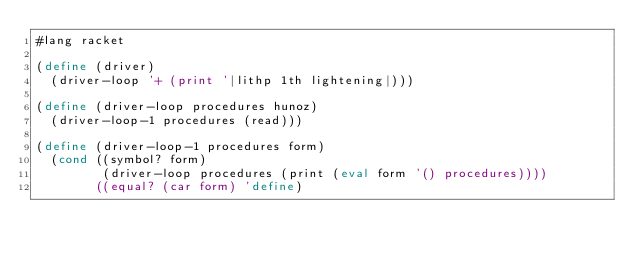Convert code to text. <code><loc_0><loc_0><loc_500><loc_500><_Scheme_>#lang racket

(define (driver)
  (driver-loop '+ (print '|lithp 1th lightening|)))

(define (driver-loop procedures hunoz)
  (driver-loop-1 procedures (read)))

(define (driver-loop-1 procedures form)
  (cond ((symbol? form)
         (driver-loop procedures (print (eval form '() procedures))))
        ((equal? (car form) 'define)</code> 